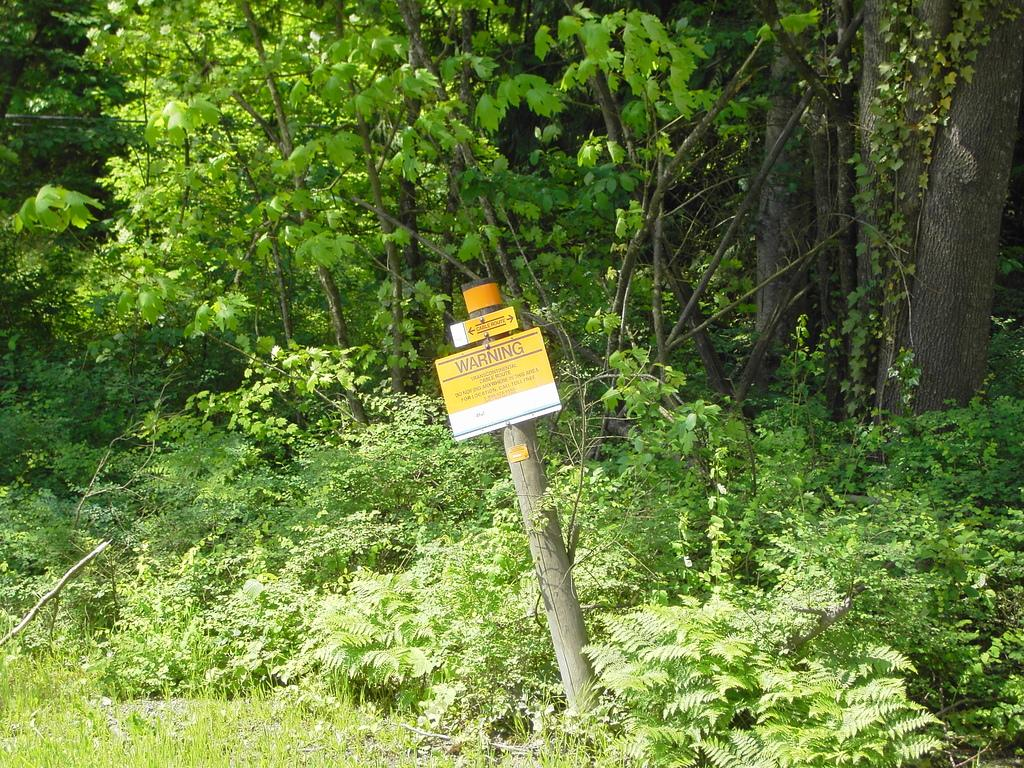What type of vegetation can be seen in the image? There is grass, plants, and trees in the image. What else is present in the image besides vegetation? There is a pole with boards in the image. Are there any words or messages on the boards? Yes, there is text on the boards. Can you see any jelly on the grass in the image? No, there is no jelly present in the image. Is there a trail visible in the image? No, there is no trail visible in the image. 